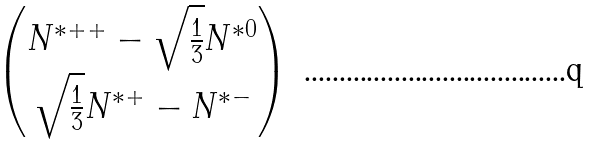<formula> <loc_0><loc_0><loc_500><loc_500>\begin{pmatrix} N ^ { * + + } - \sqrt { \frac { 1 } { 3 } } N ^ { * 0 } \\ \sqrt { \frac { 1 } { 3 } } N ^ { * + } - N ^ { * - } \end{pmatrix}</formula> 